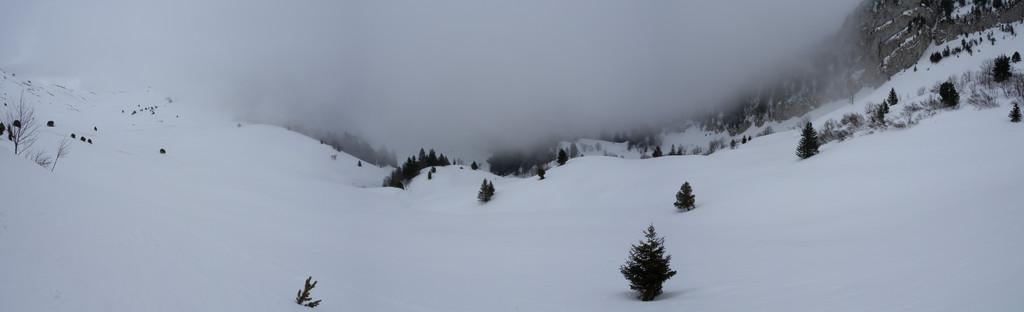What type of geographical feature is present in the image? There are mountains in the image. What type of vegetation can be seen in the image? There are many trees in the image. What is the weather like in the image? There is snow visible in the image, suggesting a cold or snowy environment. Can you see any waves in the image? There are no waves present in the image, as it features mountains and trees. What color is the orange in the image? There is no orange present in the image. Is there a yak visible in the image? There is no yak present in the image. 